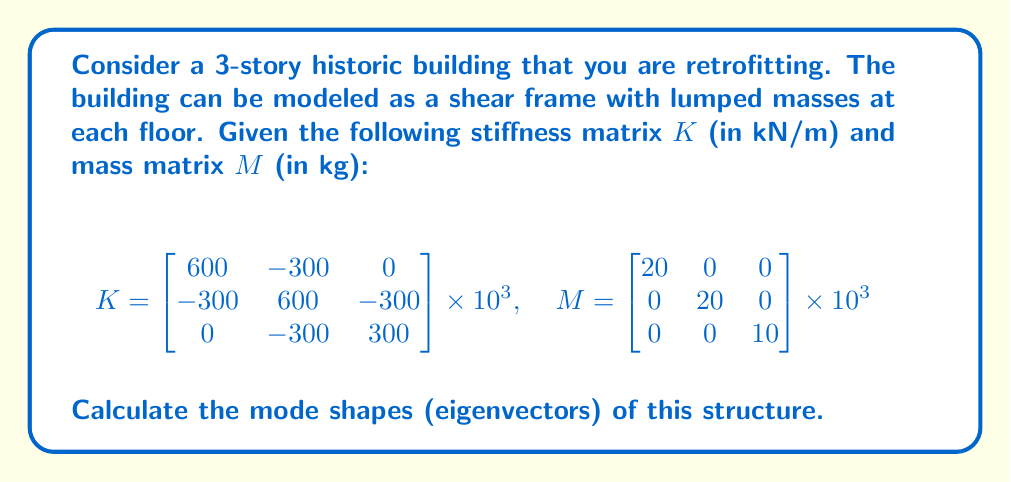Help me with this question. To calculate the mode shapes of the structure, we need to solve the generalized eigenvalue problem:

$$(K - \omega^2M)\phi = 0$$

Where $\omega^2$ are the eigenvalues and $\phi$ are the eigenvectors (mode shapes).

Step 1: Set up the characteristic equation:
$$\det(K - \omega^2M) = 0$$

Step 2: Expand the determinant:
$$\begin{vmatrix}
600 - 20\omega^2 & -300 & 0 \\
-300 & 600 - 20\omega^2 & -300 \\
0 & -300 & 300 - 10\omega^2
\end{vmatrix} \times 10^3 = 0$$

Step 3: Solve the characteristic equation. This yields the following eigenvalues:
$$\omega_1^2 = 5.858 \text{ rad}^2/\text{s}^2$$
$$\omega_2^2 = 44.142 \text{ rad}^2/\text{s}^2$$
$$\omega_3^2 = 90.000 \text{ rad}^2/\text{s}^2$$

Step 4: For each eigenvalue, solve $(K - \omega_i^2M)\phi_i = 0$ to find the corresponding eigenvector.

For $\omega_1^2$:
$$\begin{bmatrix}
482.84 & -300 & 0 \\
-300 & 482.84 & -300 \\
0 & -300 & 241.42
\end{bmatrix} \times 10^3 \begin{bmatrix}
\phi_{11} \\ \phi_{21} \\ \phi_{31}
\end{bmatrix} = 0$$

Solving this system yields the normalized eigenvector:
$$\phi_1 = \begin{bmatrix} 0.327 \\ 0.591 \\ 0.738 \end{bmatrix}$$

Similarly, for $\omega_2^2$ and $\omega_3^2$, we get:
$$\phi_2 = \begin{bmatrix} 0.738 \\ 0.327 \\ -0.591 \end{bmatrix}$$
$$\phi_3 = \begin{bmatrix} 0.591 \\ -0.738 \\ 0.327 \end{bmatrix}$$

These eigenvectors represent the mode shapes of the structure.
Answer: $\phi_1 = [0.327, 0.591, 0.738]^T$, $\phi_2 = [0.738, 0.327, -0.591]^T$, $\phi_3 = [0.591, -0.738, 0.327]^T$ 